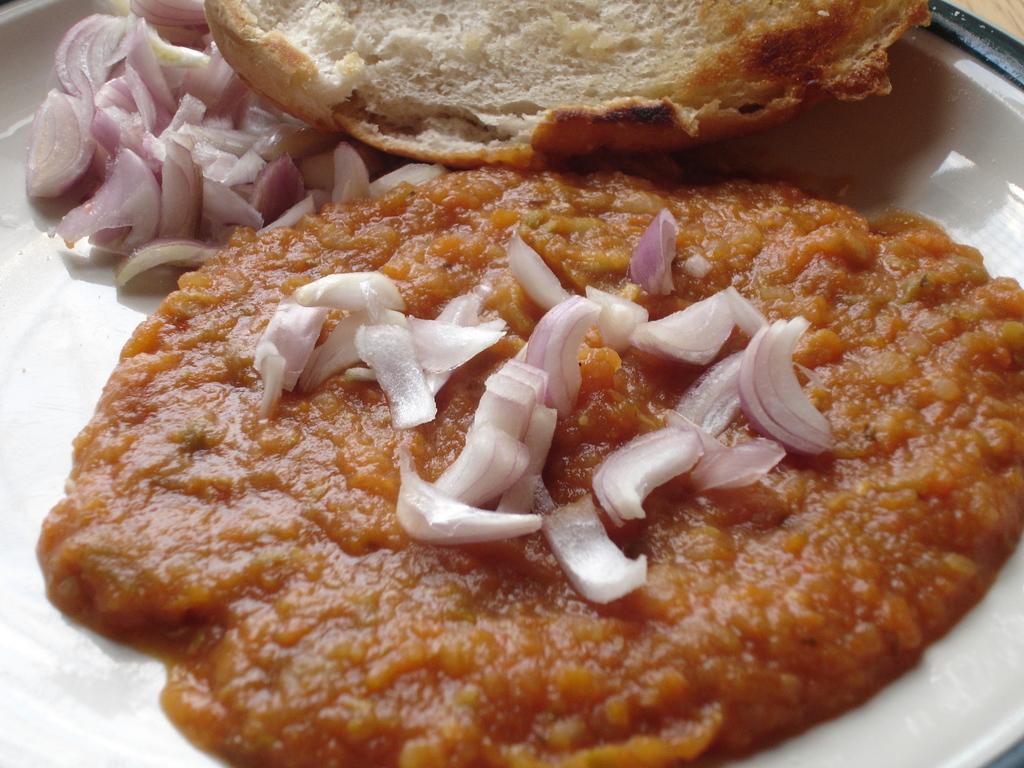How would you summarize this image in a sentence or two? In this picture we can see a plate which contains Pav bhaji with onions. 